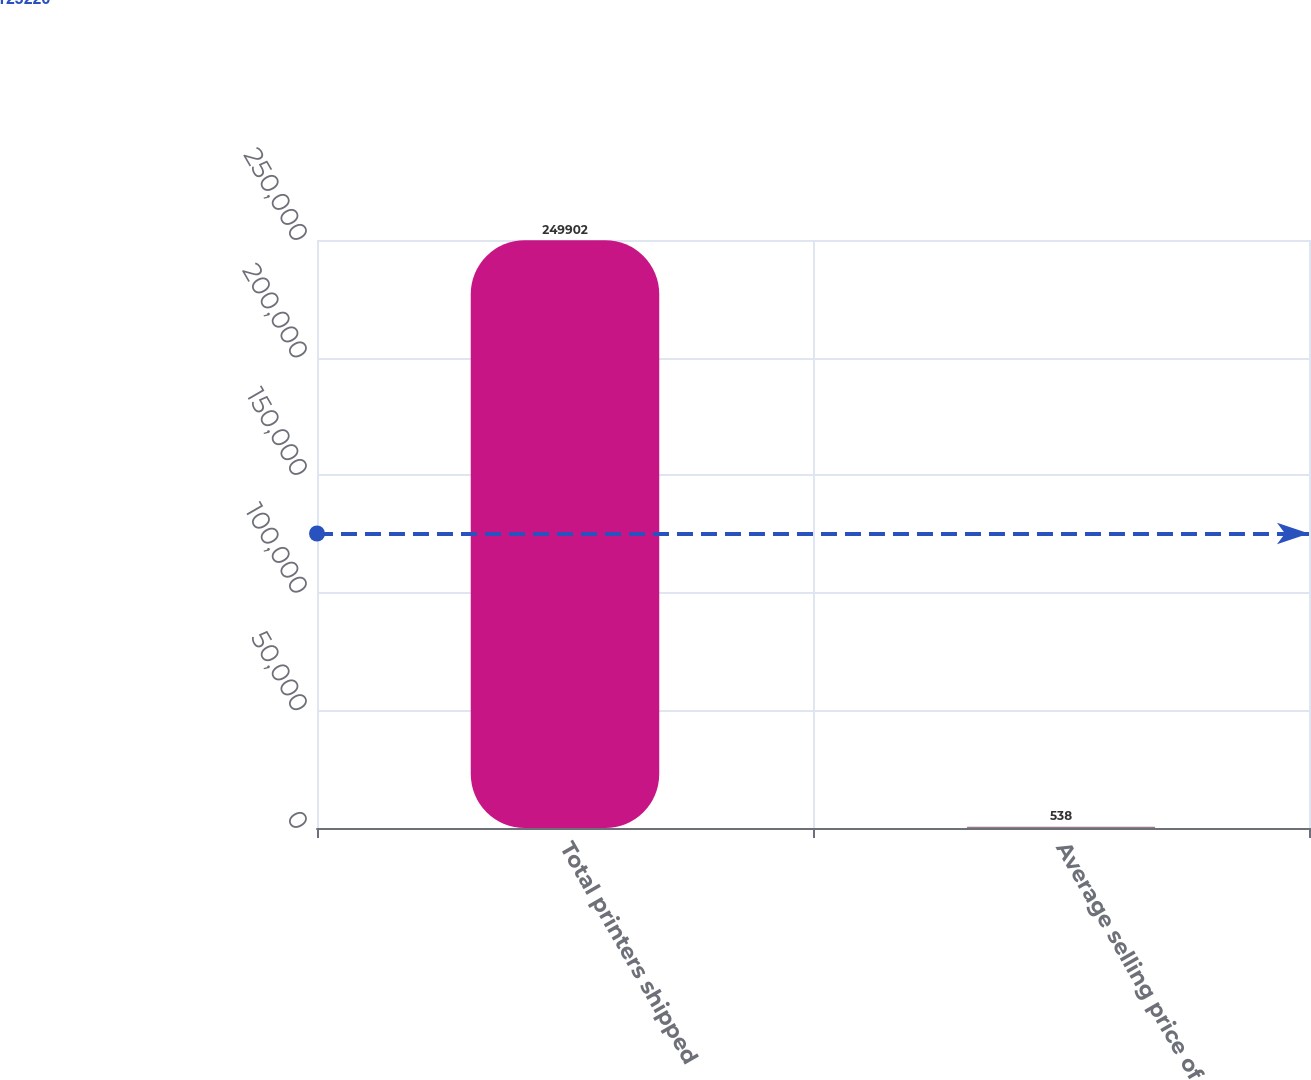Convert chart to OTSL. <chart><loc_0><loc_0><loc_500><loc_500><bar_chart><fcel>Total printers shipped<fcel>Average selling price of<nl><fcel>249902<fcel>538<nl></chart> 